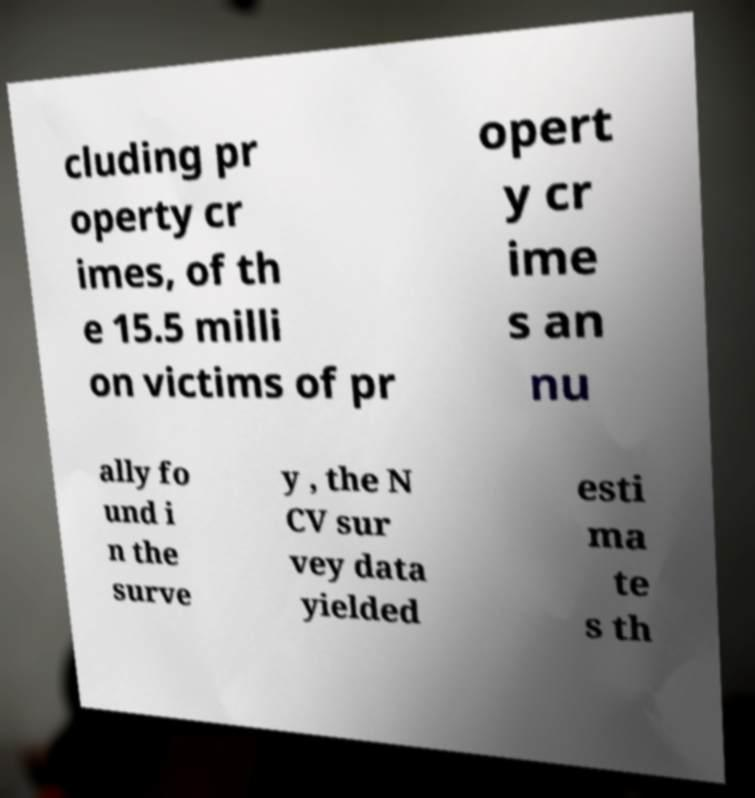Can you read and provide the text displayed in the image?This photo seems to have some interesting text. Can you extract and type it out for me? cluding pr operty cr imes, of th e 15.5 milli on victims of pr opert y cr ime s an nu ally fo und i n the surve y , the N CV sur vey data yielded esti ma te s th 